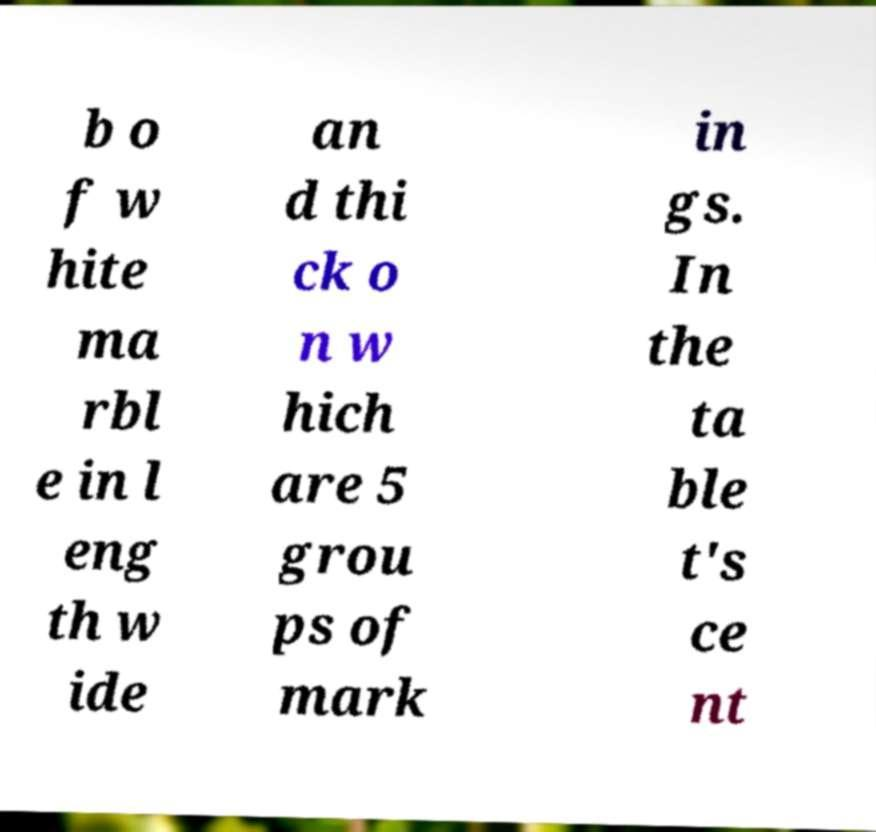I need the written content from this picture converted into text. Can you do that? b o f w hite ma rbl e in l eng th w ide an d thi ck o n w hich are 5 grou ps of mark in gs. In the ta ble t's ce nt 